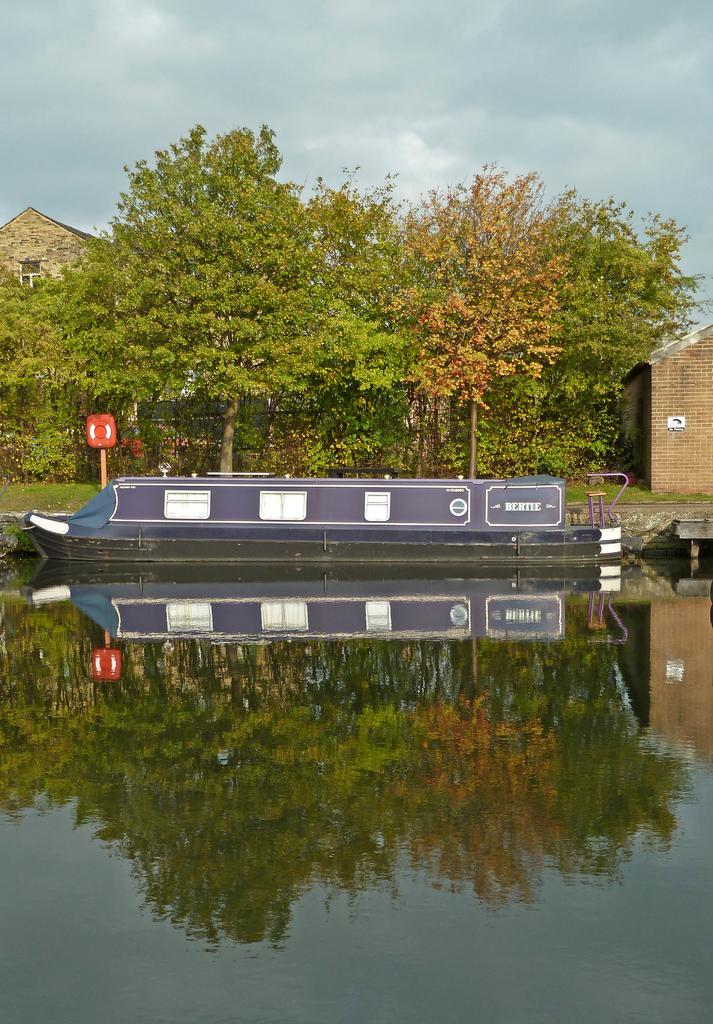What type of natural elements can be seen in the image? There are trees in the image. What type of man-made structures are present in the image? There are buildings in the image. What object in the image appears to be used for displaying information or messages? There is a board in the image. What is the object attached to a wooden stick in the image used for? It is not specified what the object attached to the wooden stick is used for, but it could be a flag, sign, or other display item. What is the water in the image reflecting? The water in the image is reflecting the trees. What part of the natural environment is visible in the image? The sky is visible in the image. What type of hair is visible on the trees in the image? There is no hair present on the trees in the image; they are natural elements with leaves and branches. What type of sign is hanging from the crib in the image? There is no crib present in the image, and therefore no sign hanging from it. 